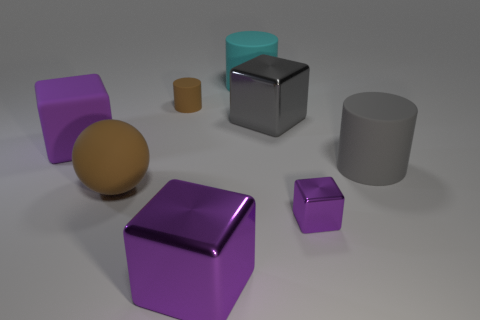Subtract all tiny brown cylinders. How many cylinders are left? 2 Add 2 purple rubber objects. How many objects exist? 10 Subtract all cyan cylinders. How many cylinders are left? 2 Subtract all cylinders. How many objects are left? 5 Subtract 2 cubes. How many cubes are left? 2 Subtract all purple cylinders. How many gray blocks are left? 1 Subtract all tiny cubes. Subtract all small matte cylinders. How many objects are left? 6 Add 7 brown cylinders. How many brown cylinders are left? 8 Add 8 small cylinders. How many small cylinders exist? 9 Subtract 3 purple cubes. How many objects are left? 5 